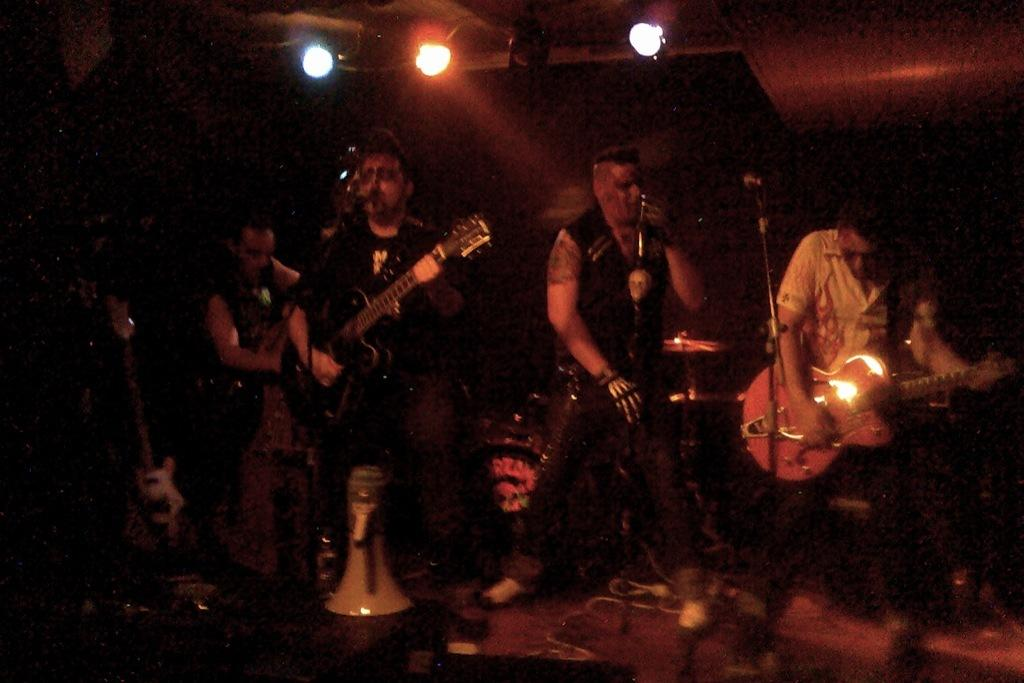What is happening on the stage in the image? There is a rock band performing on a stage. What instruments are being played by the band members? Two members of the band are playing guitars, and there is a drummer in the band. What is the role of the third member of the band? One member of the band is singing. What type of hat is the drummer wearing in the image? There is no hat visible on the drummer in the image. How does the cream enhance the performance of the band in the image? There is no cream present in the image, and it does not affect the performance of the band. 